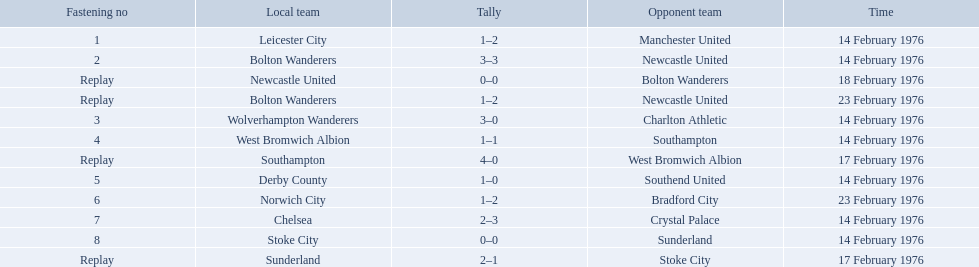What teams are featured in the game at the top of the table? Leicester City, Manchester United. Which of these two is the home team? Leicester City. What were the home teams in the 1975-76 fa cup? Leicester City, Bolton Wanderers, Newcastle United, Bolton Wanderers, Wolverhampton Wanderers, West Bromwich Albion, Southampton, Derby County, Norwich City, Chelsea, Stoke City, Sunderland. Which of these teams had the tie number 1? Leicester City. 